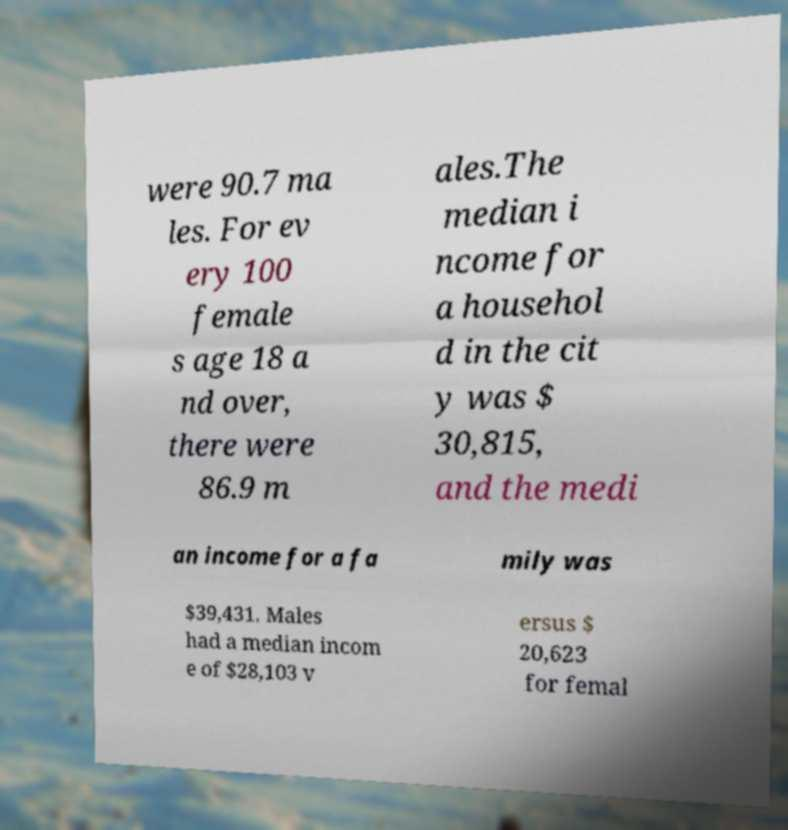Can you accurately transcribe the text from the provided image for me? were 90.7 ma les. For ev ery 100 female s age 18 a nd over, there were 86.9 m ales.The median i ncome for a househol d in the cit y was $ 30,815, and the medi an income for a fa mily was $39,431. Males had a median incom e of $28,103 v ersus $ 20,623 for femal 